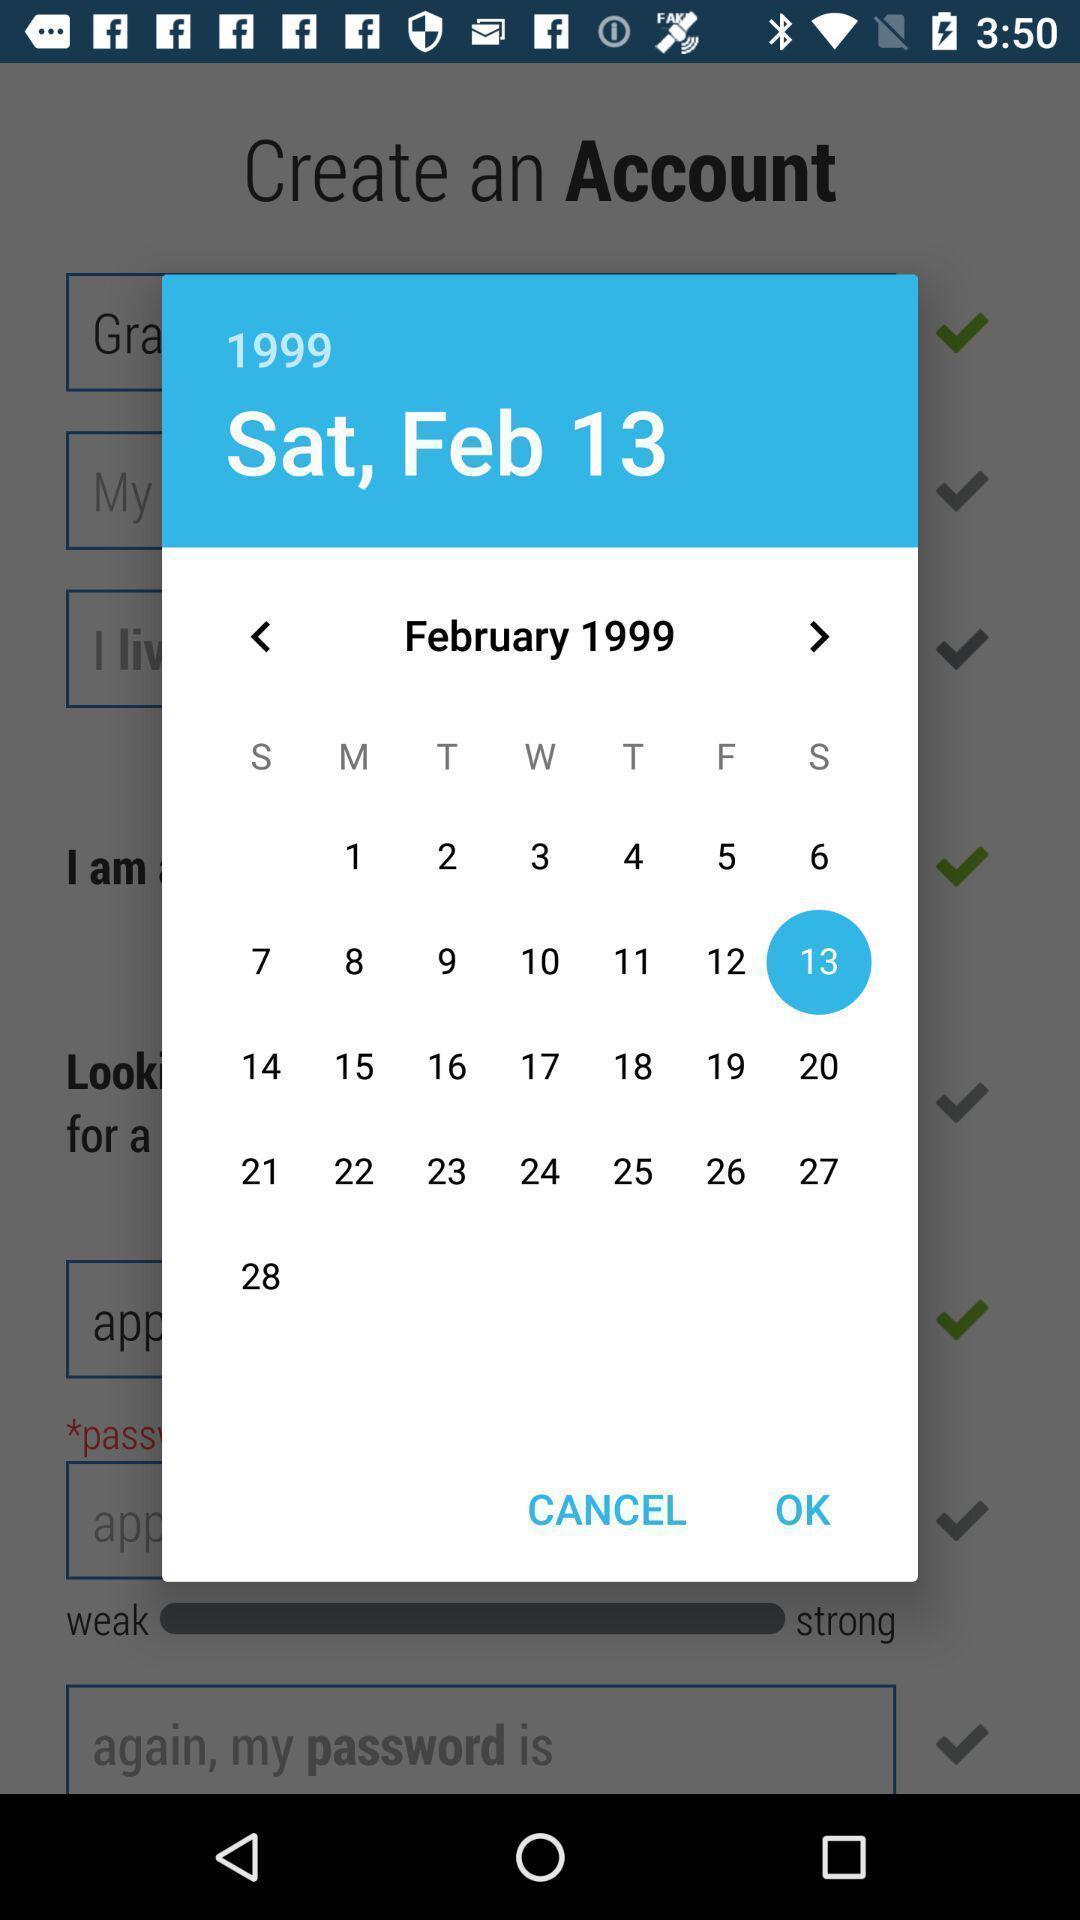What details can you identify in this image? Pop-up window showing a calendar for a month. 